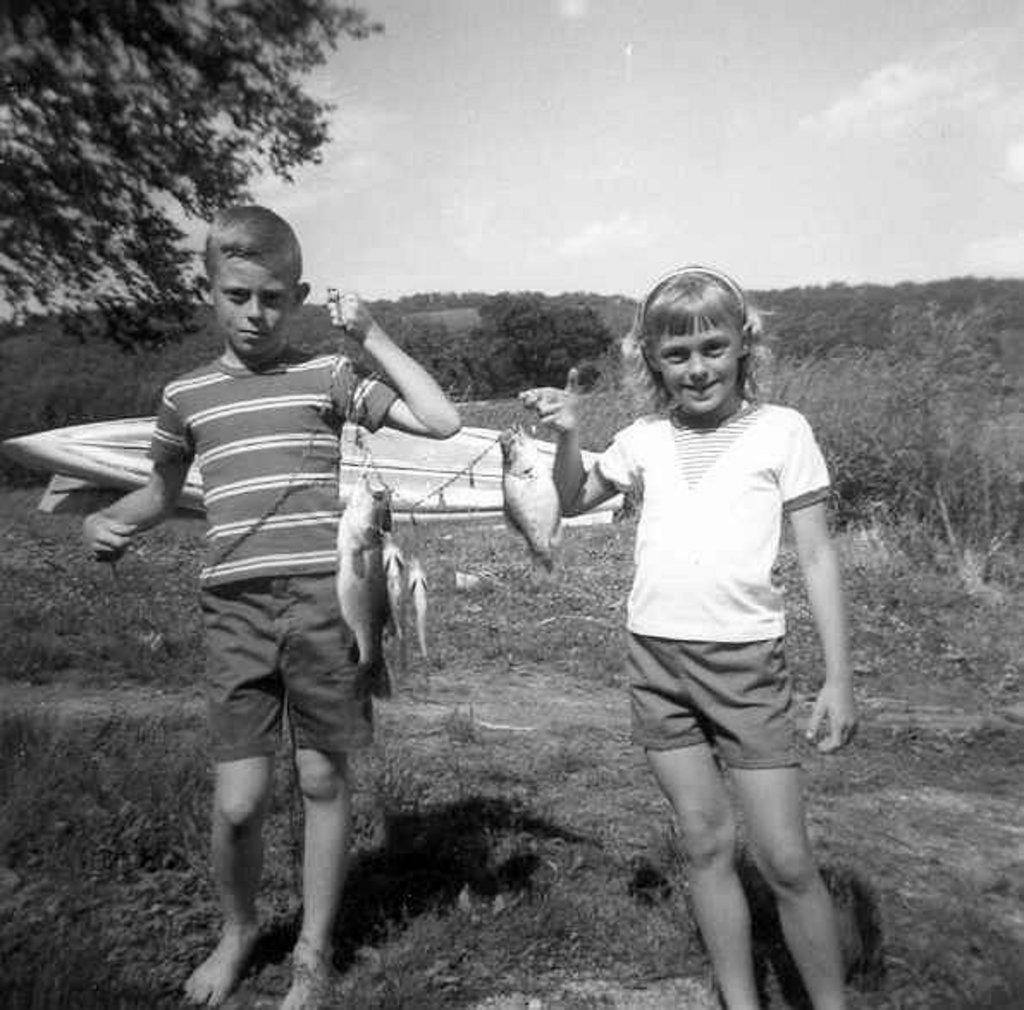Can you describe this image briefly? This is a black and white image. In this image there is a boy and a girl holding fishes. On the ground there is grass. In the back there are trees and sky. 